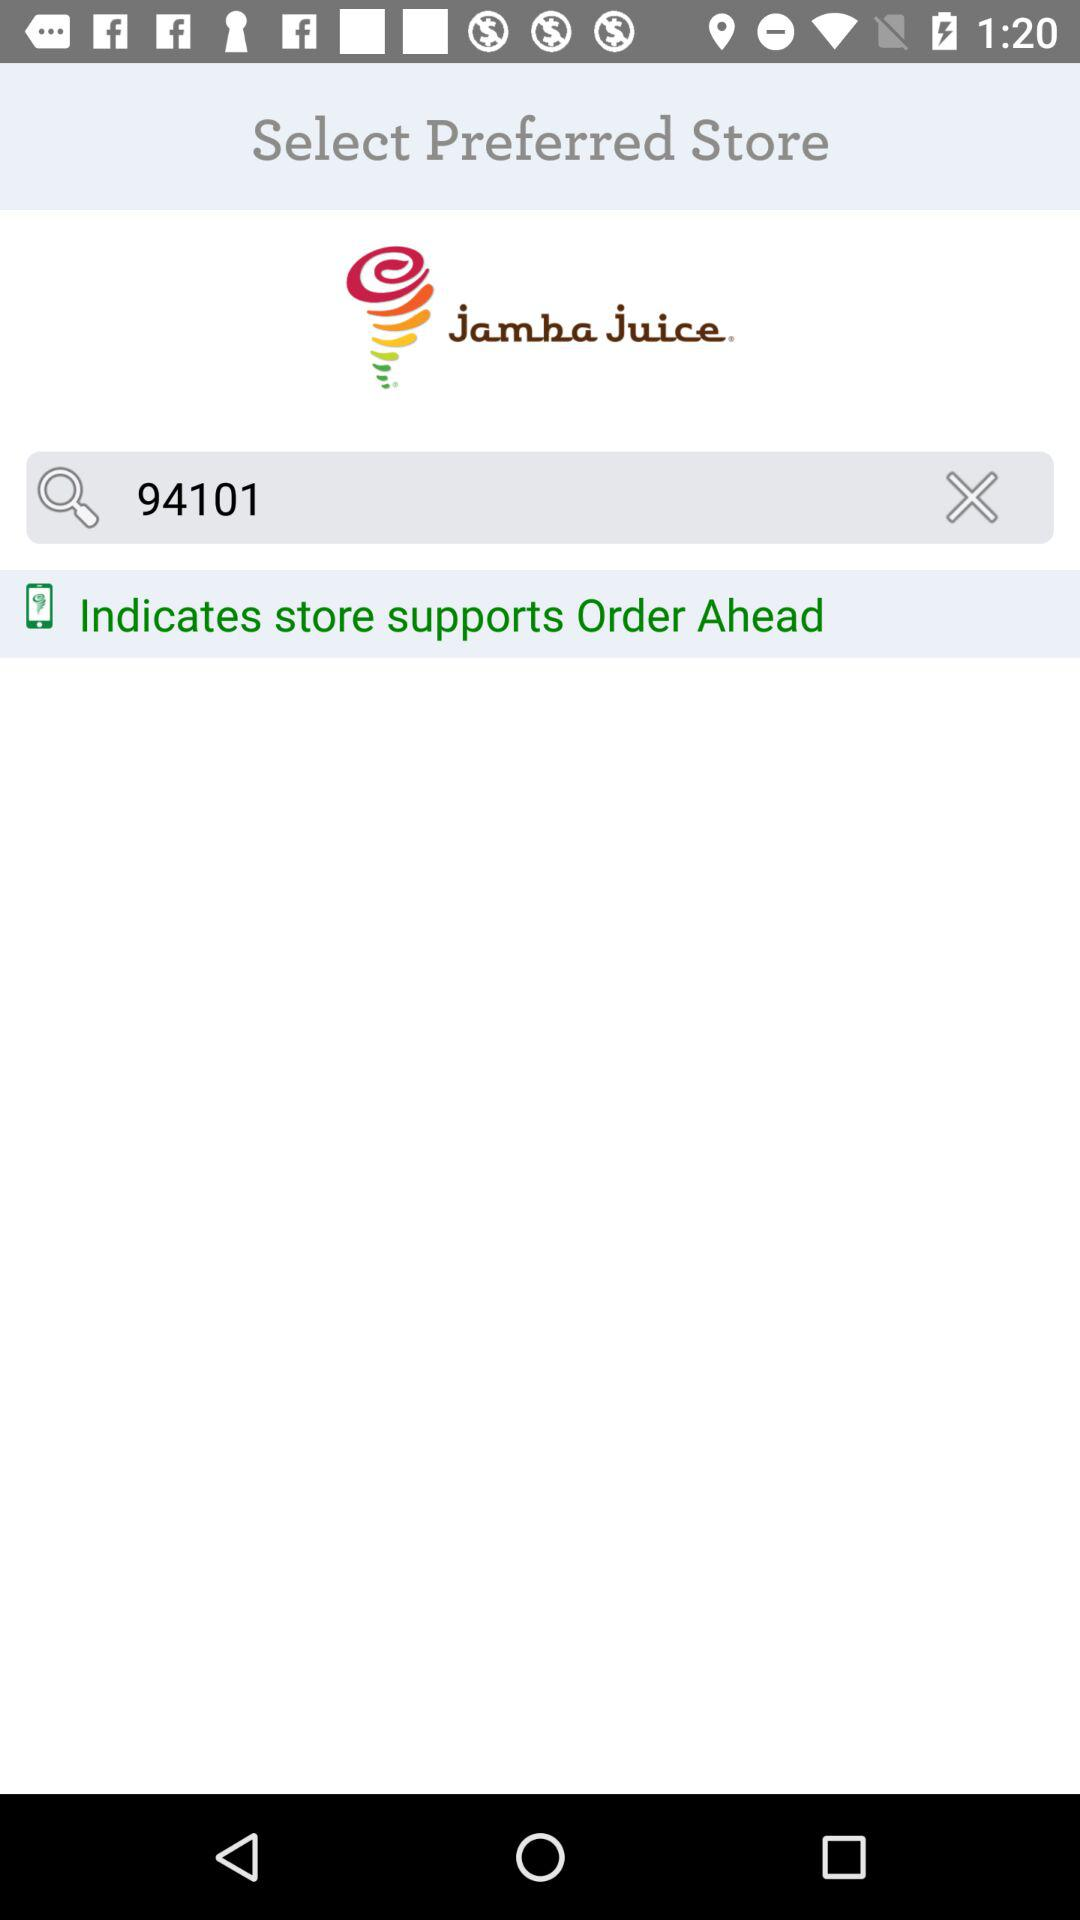What is the mentioned Zipcode?
When the provided information is insufficient, respond with <no answer>. <no answer> 